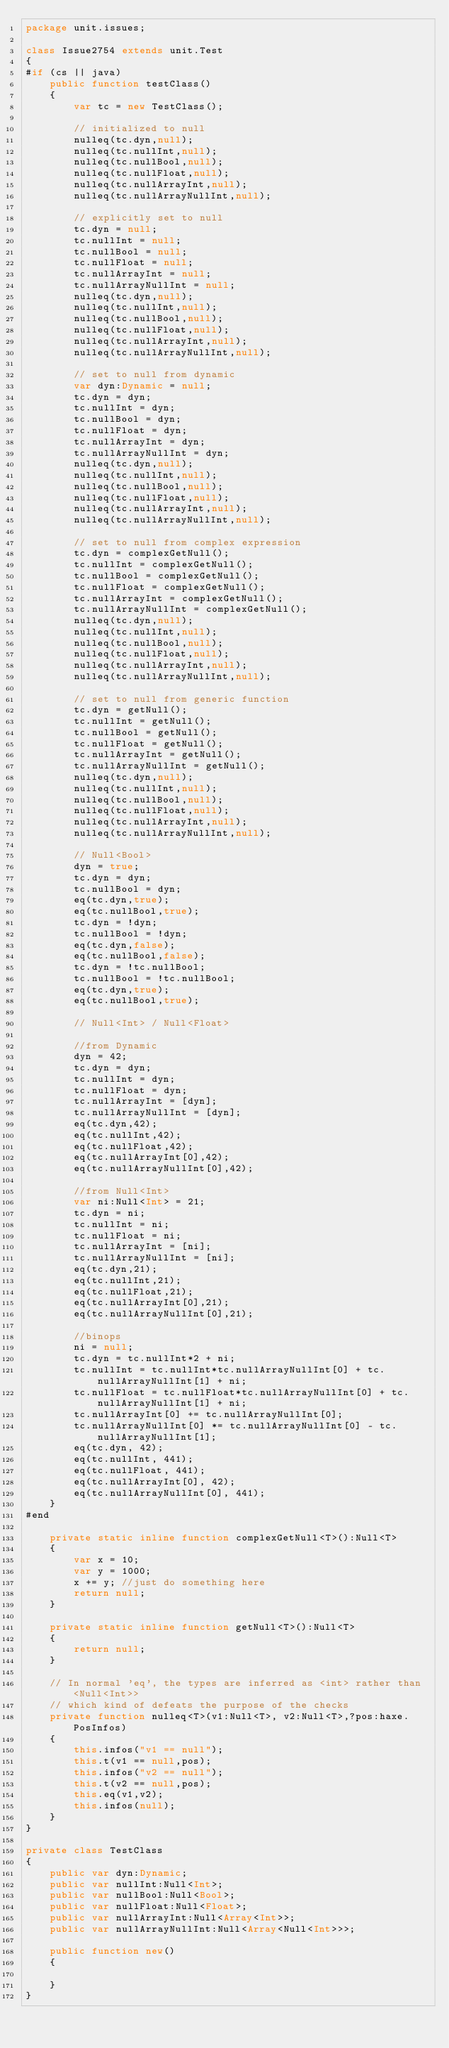<code> <loc_0><loc_0><loc_500><loc_500><_Haxe_>package unit.issues;

class Issue2754 extends unit.Test
{
#if (cs || java)
	public function testClass()
	{
		var tc = new TestClass();

		// initialized to null
		nulleq(tc.dyn,null);
		nulleq(tc.nullInt,null);
		nulleq(tc.nullBool,null);
		nulleq(tc.nullFloat,null);
		nulleq(tc.nullArrayInt,null);
		nulleq(tc.nullArrayNullInt,null);

		// explicitly set to null
		tc.dyn = null;
		tc.nullInt = null;
		tc.nullBool = null;
		tc.nullFloat = null;
		tc.nullArrayInt = null;
		tc.nullArrayNullInt = null;
		nulleq(tc.dyn,null);
		nulleq(tc.nullInt,null);
		nulleq(tc.nullBool,null);
		nulleq(tc.nullFloat,null);
		nulleq(tc.nullArrayInt,null);
		nulleq(tc.nullArrayNullInt,null);

		// set to null from dynamic
		var dyn:Dynamic = null;
		tc.dyn = dyn;
		tc.nullInt = dyn;
		tc.nullBool = dyn;
		tc.nullFloat = dyn;
		tc.nullArrayInt = dyn;
		tc.nullArrayNullInt = dyn;
		nulleq(tc.dyn,null);
		nulleq(tc.nullInt,null);
		nulleq(tc.nullBool,null);
		nulleq(tc.nullFloat,null);
		nulleq(tc.nullArrayInt,null);
		nulleq(tc.nullArrayNullInt,null);

		// set to null from complex expression
		tc.dyn = complexGetNull();
		tc.nullInt = complexGetNull();
		tc.nullBool = complexGetNull();
		tc.nullFloat = complexGetNull();
		tc.nullArrayInt = complexGetNull();
		tc.nullArrayNullInt = complexGetNull();
		nulleq(tc.dyn,null);
		nulleq(tc.nullInt,null);
		nulleq(tc.nullBool,null);
		nulleq(tc.nullFloat,null);
		nulleq(tc.nullArrayInt,null);
		nulleq(tc.nullArrayNullInt,null);

		// set to null from generic function
		tc.dyn = getNull();
		tc.nullInt = getNull();
		tc.nullBool = getNull();
		tc.nullFloat = getNull();
		tc.nullArrayInt = getNull();
		tc.nullArrayNullInt = getNull();
		nulleq(tc.dyn,null);
		nulleq(tc.nullInt,null);
		nulleq(tc.nullBool,null);
		nulleq(tc.nullFloat,null);
		nulleq(tc.nullArrayInt,null);
		nulleq(tc.nullArrayNullInt,null);

		// Null<Bool>
		dyn = true;
		tc.dyn = dyn;
		tc.nullBool = dyn;
		eq(tc.dyn,true);
		eq(tc.nullBool,true);
		tc.dyn = !dyn;
		tc.nullBool = !dyn;
		eq(tc.dyn,false);
		eq(tc.nullBool,false);
		tc.dyn = !tc.nullBool;
		tc.nullBool = !tc.nullBool;
		eq(tc.dyn,true);
		eq(tc.nullBool,true);

		// Null<Int> / Null<Float>

		//from Dynamic
		dyn = 42;
		tc.dyn = dyn;
		tc.nullInt = dyn;
		tc.nullFloat = dyn;
		tc.nullArrayInt = [dyn];
		tc.nullArrayNullInt = [dyn];
		eq(tc.dyn,42);
		eq(tc.nullInt,42);
		eq(tc.nullFloat,42);
		eq(tc.nullArrayInt[0],42);
		eq(tc.nullArrayNullInt[0],42);

		//from Null<Int>
		var ni:Null<Int> = 21;
		tc.dyn = ni;
		tc.nullInt = ni;
		tc.nullFloat = ni;
		tc.nullArrayInt = [ni];
		tc.nullArrayNullInt = [ni];
		eq(tc.dyn,21);
		eq(tc.nullInt,21);
		eq(tc.nullFloat,21);
		eq(tc.nullArrayInt[0],21);
		eq(tc.nullArrayNullInt[0],21);

		//binops
		ni = null;
		tc.dyn = tc.nullInt*2 + ni;
		tc.nullInt = tc.nullInt*tc.nullArrayNullInt[0] + tc.nullArrayNullInt[1] + ni;
		tc.nullFloat = tc.nullFloat*tc.nullArrayNullInt[0] + tc.nullArrayNullInt[1] + ni;
		tc.nullArrayInt[0] += tc.nullArrayNullInt[0];
		tc.nullArrayNullInt[0] *= tc.nullArrayNullInt[0] - tc.nullArrayNullInt[1];
		eq(tc.dyn, 42);
		eq(tc.nullInt, 441);
		eq(tc.nullFloat, 441);
		eq(tc.nullArrayInt[0], 42);
		eq(tc.nullArrayNullInt[0], 441);
	}
#end

	private static inline function complexGetNull<T>():Null<T>
	{
		var x = 10;
		var y = 1000;
		x += y; //just do something here
		return null;
	}

	private static inline function getNull<T>():Null<T>
	{
		return null;
	}

	// In normal 'eq', the types are inferred as <int> rather than <Null<Int>>
	// which kind of defeats the purpose of the checks
	private function nulleq<T>(v1:Null<T>, v2:Null<T>,?pos:haxe.PosInfos)
	{
		this.infos("v1 == null");
		this.t(v1 == null,pos);
		this.infos("v2 == null");
		this.t(v2 == null,pos);
		this.eq(v1,v2);
		this.infos(null);
	}
}

private class TestClass
{
	public var dyn:Dynamic;
	public var nullInt:Null<Int>;
	public var nullBool:Null<Bool>;
	public var nullFloat:Null<Float>;
	public var nullArrayInt:Null<Array<Int>>;
	public var nullArrayNullInt:Null<Array<Null<Int>>>;

	public function new()
	{

	}
}
</code> 